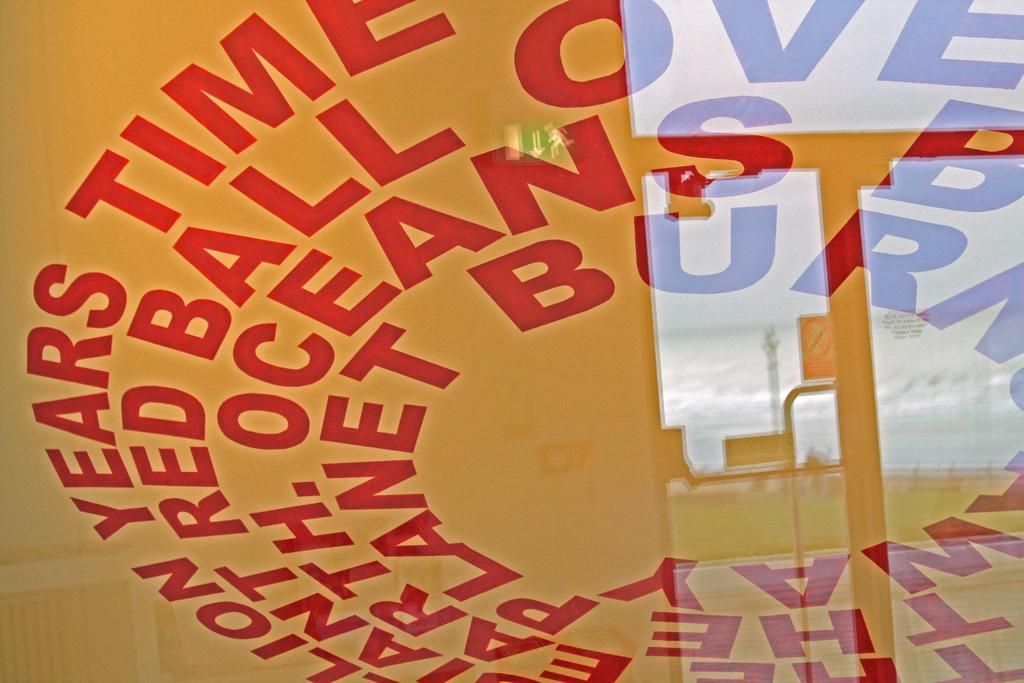<image>
Create a compact narrative representing the image presented. The word time is on a sign that has words in a circle. 